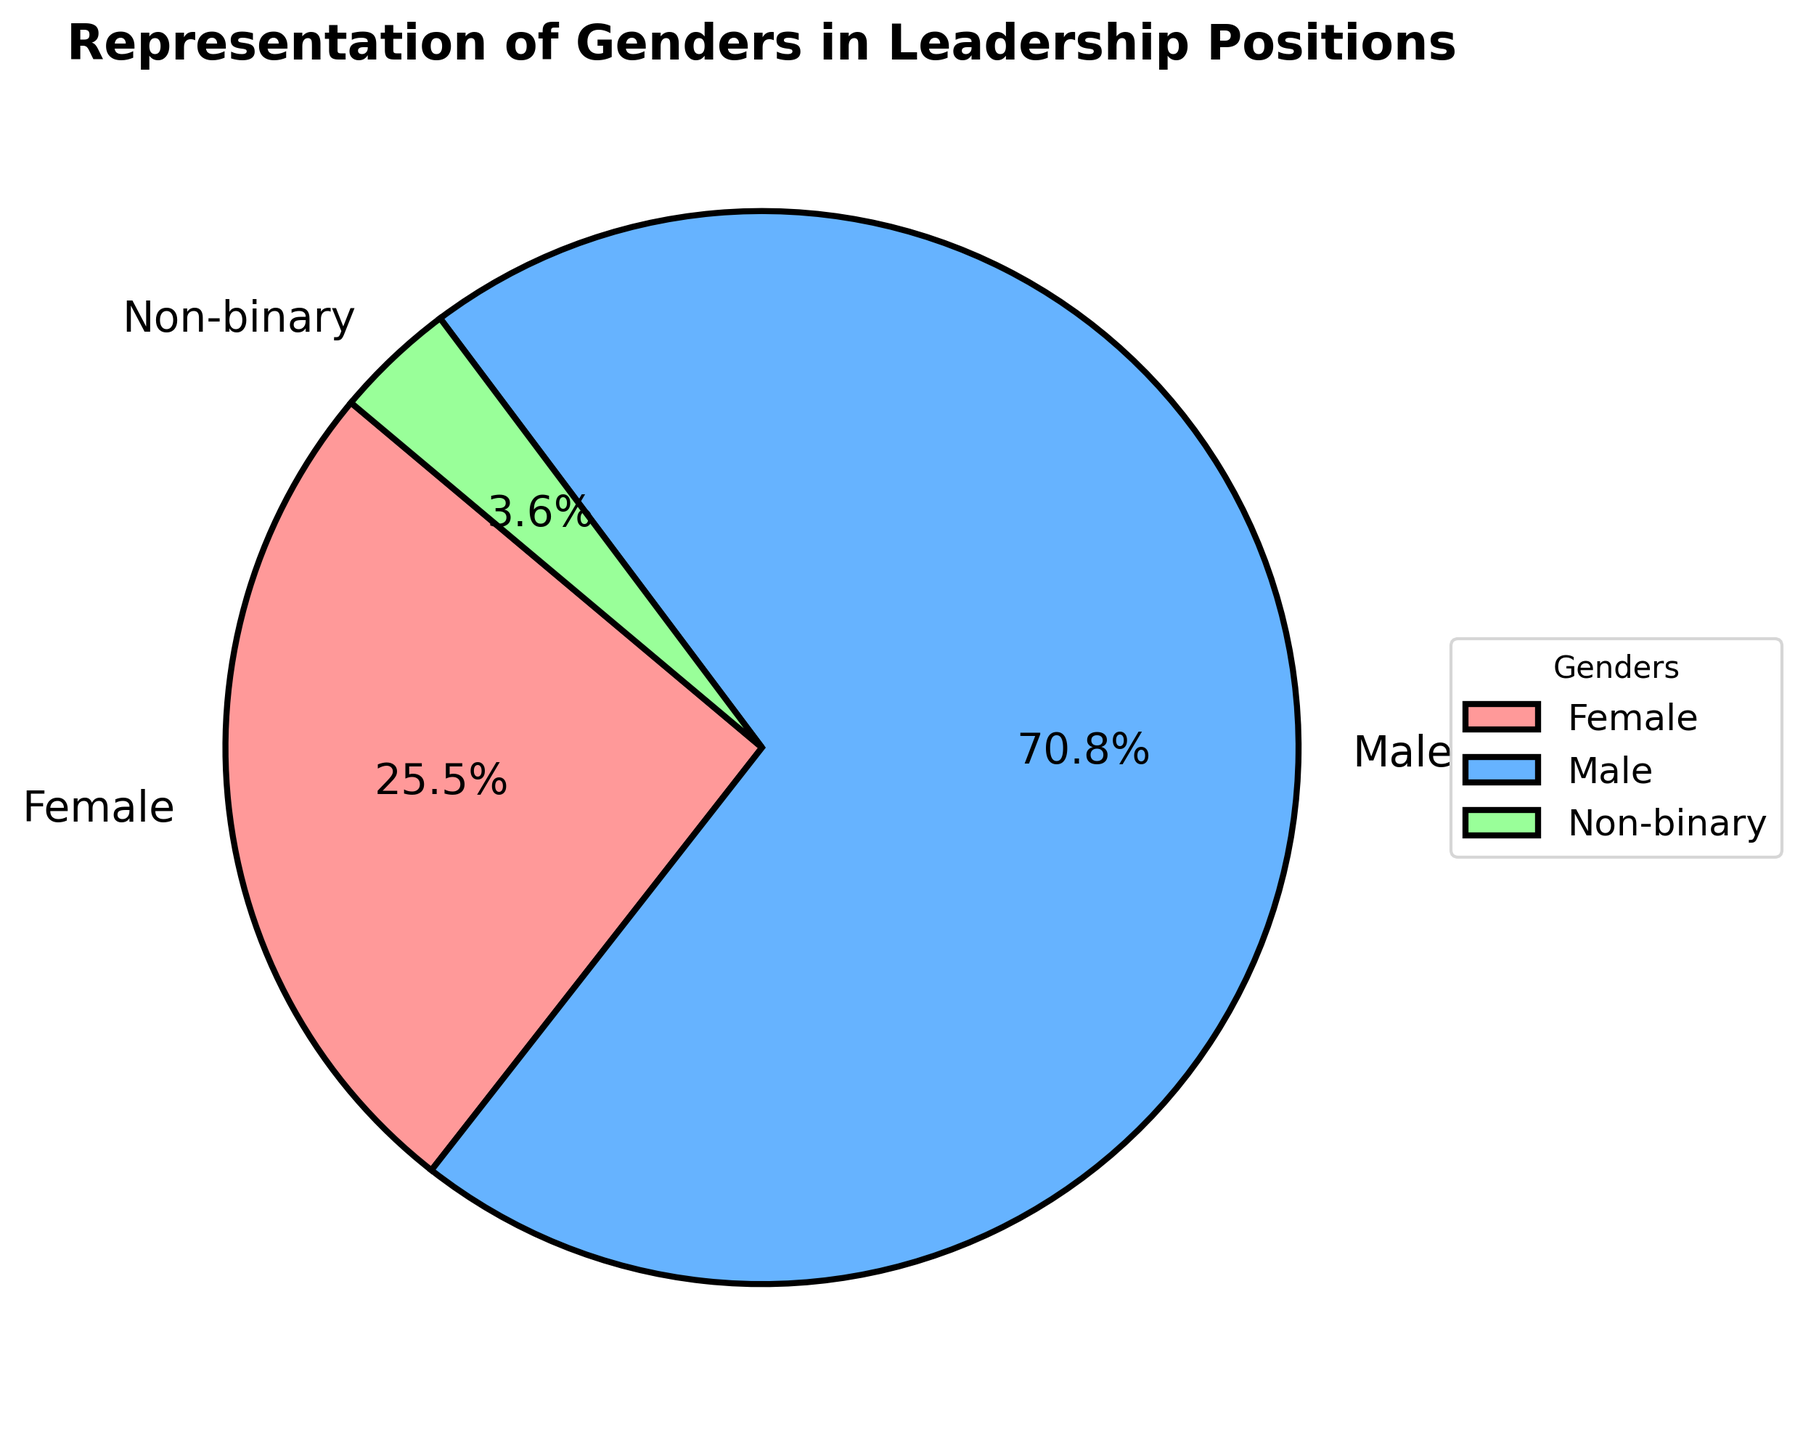What's the percentage of males in leadership positions? The figure shows a pie chart with the proportion of males, females, and non-binary individuals in leadership positions. To find the percentage of males, locate the segment of the chart labeled 'Male' and read the percentage displayed.
Answer: 68.0% Which gender occupies the second largest share of leadership positions? By observing the pie chart, identify the segment that is the second largest after the 'Male' segment. This segment is labeled 'Female'.
Answer: Female What is the combined percentage of non-binary individuals and females in leadership positions? According to the pie chart, non-binary individuals occupy 3.8% and females occupy 23.9%. Adding these percentages gives the combined percentage: 3.8% + 23.9% = 27.7%.
Answer: 27.7% Is the proportion of females in leadership positions greater than 20%? Look at the segment labeled 'Female' in the pie chart and check if the percentage displayed is greater than 20%. The figure shows it as 23.9%.
Answer: Yes What is the difference in representation between males and non-binary individuals in leadership positions? The pie chart shows the percentage of males is 68.0% and that of non-binary individuals is 3.8%. The difference is 68.0% - 3.8% = 64.2%.
Answer: 64.2% Which gender has the smallest representation in leadership positions? Identify the smallest segment in the pie chart, which is labeled 'Non-binary'.
Answer: Non-binary How many times larger is the representation of males compared to non-binary individuals in leadership positions? From the pie chart, males represent 68.0% and non-binary individuals represent 3.8%. The ratio is calculated by dividing the percentage of males by the percentage of non-binary: 68.0% / 3.8% = 17.89, approximately 18 times larger.
Answer: 18 times What is the sum of the representations of all genders in leadership positions? The sum of all the percentages in a pie chart is 100% as it represents the whole data set.
Answer: 100% Is the proportion of females less than one-third of the total leadership positions? One-third of 100% is about 33.3%. The percentage of females, as seen in the pie chart, is 23.9%, which is less than 33.3%.
Answer: Yes Which visual attribute most clearly shows that males dominate the leadership positions? The size of the segment for males in the pie chart is the largest, making it visually apparent that males dominate leadership positions.
Answer: Segment size 